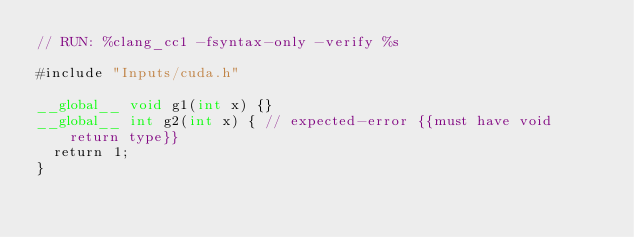<code> <loc_0><loc_0><loc_500><loc_500><_Cuda_>// RUN: %clang_cc1 -fsyntax-only -verify %s

#include "Inputs/cuda.h"

__global__ void g1(int x) {}
__global__ int g2(int x) { // expected-error {{must have void return type}}
  return 1;
}
</code> 